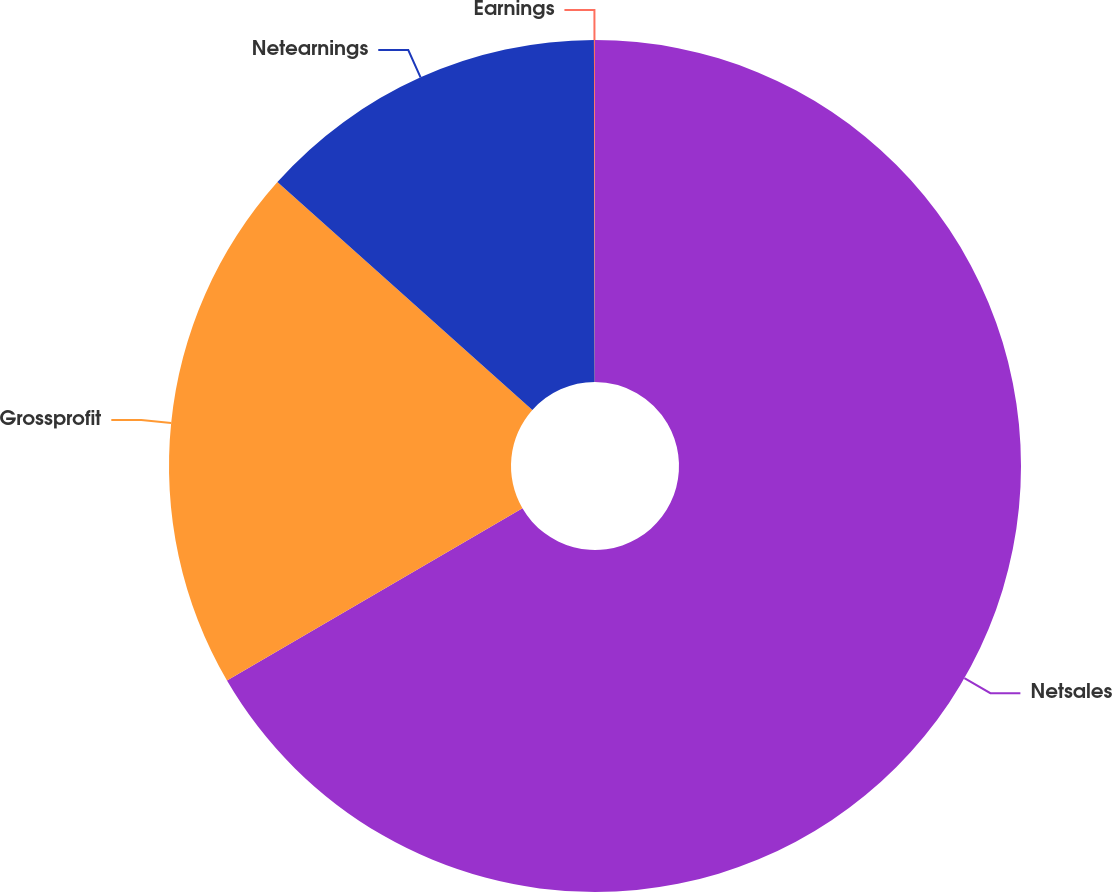Convert chart to OTSL. <chart><loc_0><loc_0><loc_500><loc_500><pie_chart><fcel>Netsales<fcel>Grossprofit<fcel>Netearnings<fcel>Earnings<nl><fcel>66.6%<fcel>20.01%<fcel>13.35%<fcel>0.04%<nl></chart> 